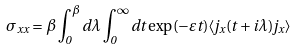<formula> <loc_0><loc_0><loc_500><loc_500>\sigma _ { x x } = \beta \int _ { 0 } ^ { \beta } d \lambda \int _ { 0 } ^ { \infty } d t \exp ( - \varepsilon t ) \langle j _ { x } ( t + i \lambda ) j _ { x } \rangle</formula> 